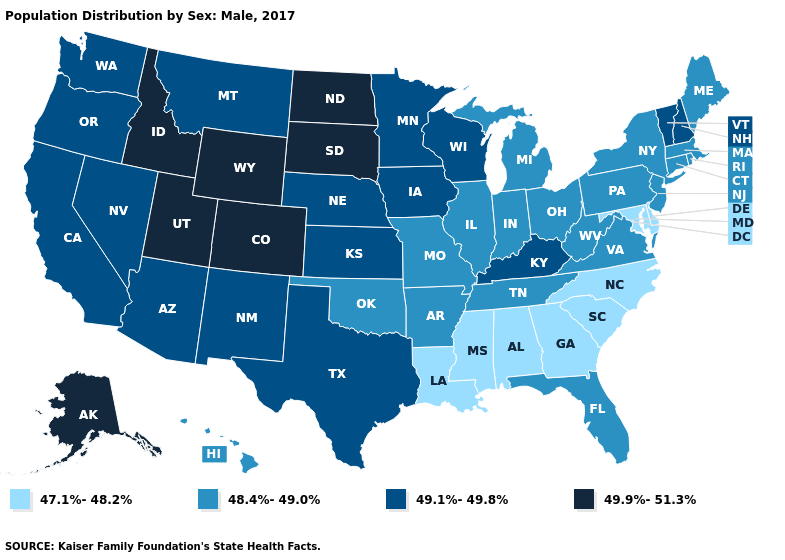Name the states that have a value in the range 48.4%-49.0%?
Short answer required. Arkansas, Connecticut, Florida, Hawaii, Illinois, Indiana, Maine, Massachusetts, Michigan, Missouri, New Jersey, New York, Ohio, Oklahoma, Pennsylvania, Rhode Island, Tennessee, Virginia, West Virginia. What is the lowest value in the USA?
Keep it brief. 47.1%-48.2%. Among the states that border Tennessee , which have the highest value?
Give a very brief answer. Kentucky. What is the value of Vermont?
Answer briefly. 49.1%-49.8%. Name the states that have a value in the range 49.9%-51.3%?
Quick response, please. Alaska, Colorado, Idaho, North Dakota, South Dakota, Utah, Wyoming. What is the lowest value in the USA?
Concise answer only. 47.1%-48.2%. Is the legend a continuous bar?
Concise answer only. No. Name the states that have a value in the range 49.9%-51.3%?
Give a very brief answer. Alaska, Colorado, Idaho, North Dakota, South Dakota, Utah, Wyoming. Among the states that border Kentucky , which have the lowest value?
Give a very brief answer. Illinois, Indiana, Missouri, Ohio, Tennessee, Virginia, West Virginia. Among the states that border Louisiana , does Arkansas have the lowest value?
Write a very short answer. No. What is the value of Kentucky?
Be succinct. 49.1%-49.8%. Name the states that have a value in the range 47.1%-48.2%?
Short answer required. Alabama, Delaware, Georgia, Louisiana, Maryland, Mississippi, North Carolina, South Carolina. Does Kansas have the same value as Mississippi?
Keep it brief. No. Name the states that have a value in the range 47.1%-48.2%?
Answer briefly. Alabama, Delaware, Georgia, Louisiana, Maryland, Mississippi, North Carolina, South Carolina. 